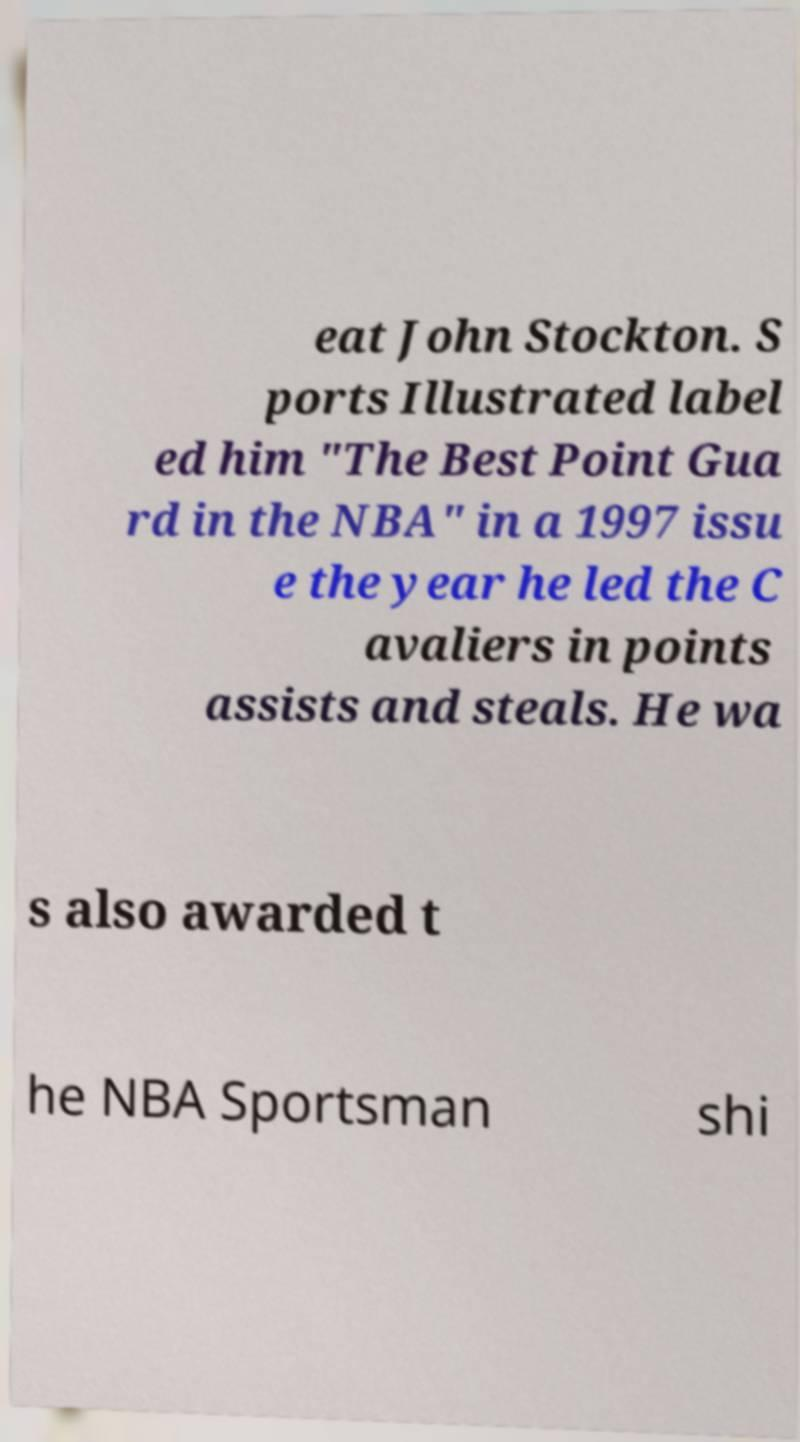For documentation purposes, I need the text within this image transcribed. Could you provide that? eat John Stockton. S ports Illustrated label ed him "The Best Point Gua rd in the NBA" in a 1997 issu e the year he led the C avaliers in points assists and steals. He wa s also awarded t he NBA Sportsman shi 